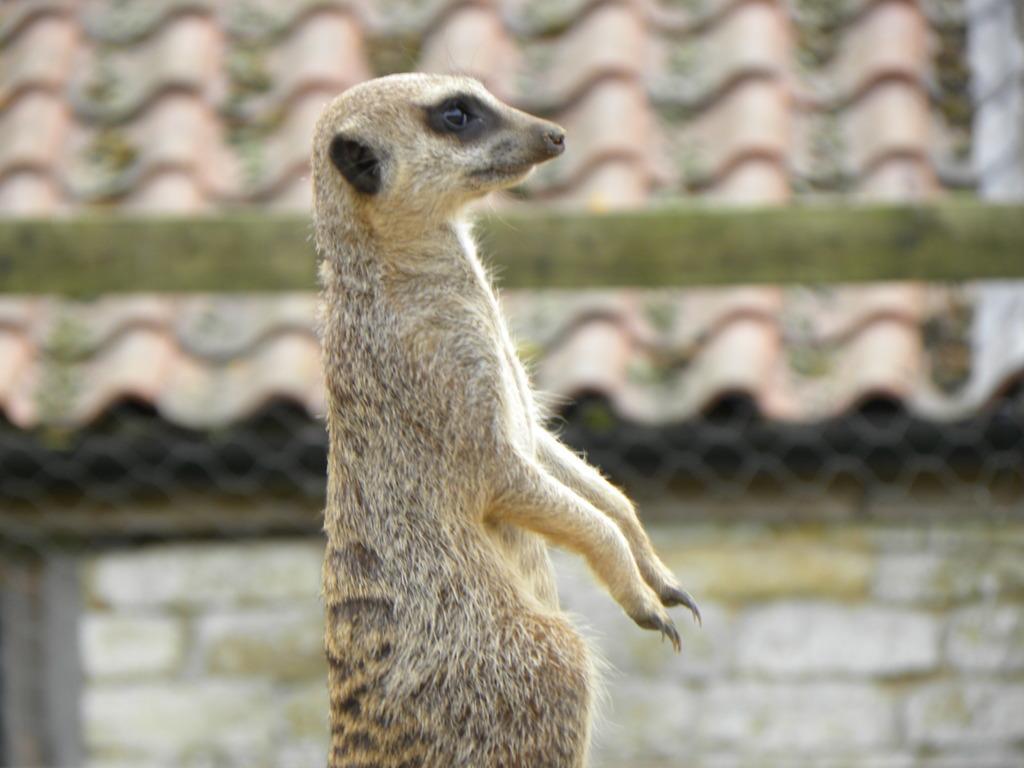Can you describe this image briefly? In this image I can see an animal which is in black and cream color. It is to the side of the house. And I can see the brown color roof of the house. 